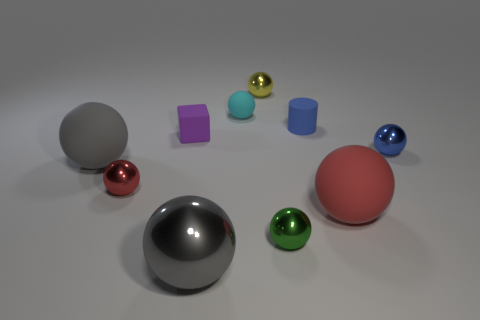Subtract all cyan matte balls. How many balls are left? 7 Subtract all cyan balls. How many balls are left? 7 Subtract 1 spheres. How many spheres are left? 7 Subtract all blocks. How many objects are left? 9 Add 8 big red rubber objects. How many big red rubber objects exist? 9 Subtract 0 purple balls. How many objects are left? 10 Subtract all cyan spheres. Subtract all gray cylinders. How many spheres are left? 7 Subtract all gray cubes. How many brown cylinders are left? 0 Subtract all green cylinders. Subtract all yellow objects. How many objects are left? 9 Add 3 blue balls. How many blue balls are left? 4 